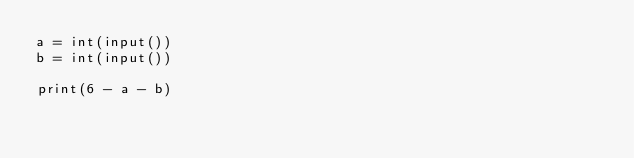<code> <loc_0><loc_0><loc_500><loc_500><_Python_>a = int(input())
b = int(input())

print(6 - a - b)
</code> 